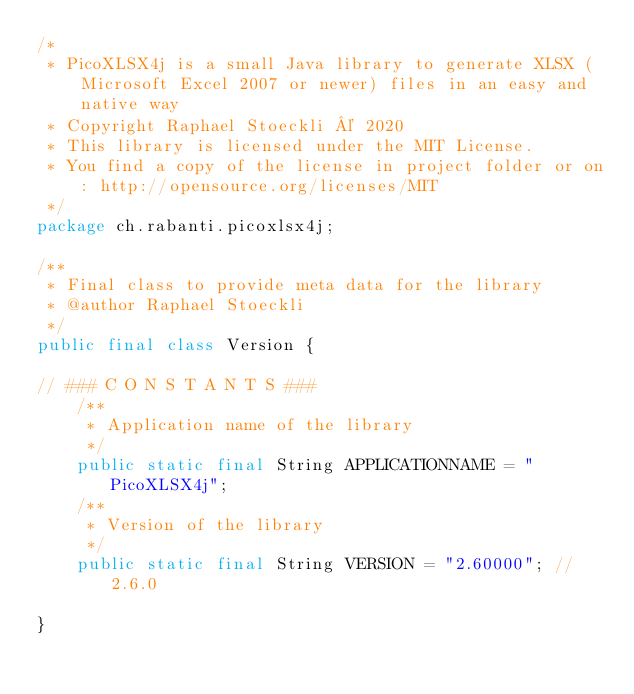Convert code to text. <code><loc_0><loc_0><loc_500><loc_500><_Java_>/*
 * PicoXLSX4j is a small Java library to generate XLSX (Microsoft Excel 2007 or newer) files in an easy and native way
 * Copyright Raphael Stoeckli © 2020
 * This library is licensed under the MIT License.
 * You find a copy of the license in project folder or on: http://opensource.org/licenses/MIT
 */
package ch.rabanti.picoxlsx4j;

/**
 * Final class to provide meta data for the library 
 * @author Raphael Stoeckli
 */
public final class Version {
    
// ### C O N S T A N T S ###    
    /**
     * Application name of the library
     */
    public static final String APPLICATIONNAME = "PicoXLSX4j";
    /**
     * Version of the library
     */
    public static final String VERSION = "2.60000"; // 2.6.0
    
}
</code> 